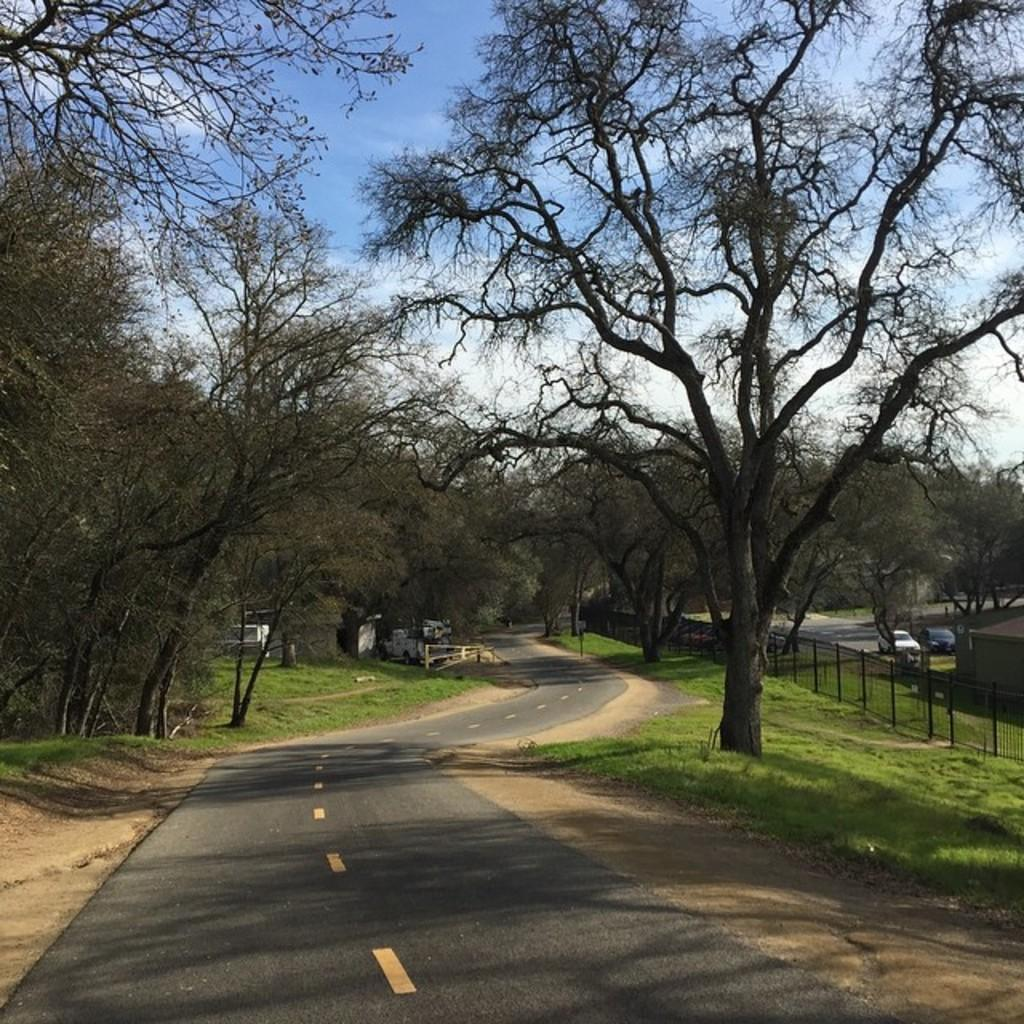What is in the foreground of the image? There is a road in the foreground of the image. What can be seen in the image besides the road? Trees, vehicles, a boundary, and houses are visible in the image. What is the condition of the sky in the image? The sky is visible in the background of the image. What type of nerve can be seen in the image? There is no nerve present in the image. What kind of apparatus is being used by the yak in the image? There is no yak present in the image, and therefore no apparatus can be associated with it. 